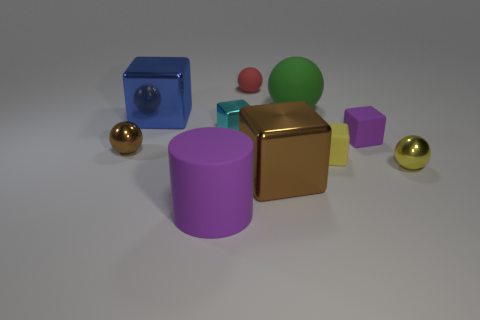The brown metallic object that is the same shape as the large green thing is what size?
Provide a short and direct response. Small. There is a tiny sphere left of the small ball behind the large green thing; how many small metal things are in front of it?
Give a very brief answer. 1. What is the color of the small ball on the right side of the tiny matte object to the left of the big green matte object?
Provide a short and direct response. Yellow. How many other objects are the same material as the big blue cube?
Ensure brevity in your answer.  4. There is a large metal thing in front of the small purple object; what number of tiny red rubber things are right of it?
Provide a short and direct response. 0. Are there any other things that have the same shape as the big blue thing?
Offer a terse response. Yes. There is a shiny ball to the left of the brown block; is its color the same as the thing that is in front of the brown metallic cube?
Your answer should be very brief. No. Is the number of small purple matte things less than the number of red cylinders?
Your answer should be compact. No. There is a tiny thing that is on the right side of the small block on the right side of the small yellow block; what shape is it?
Keep it short and to the point. Sphere. Is there anything else that has the same size as the cyan metal thing?
Ensure brevity in your answer.  Yes. 